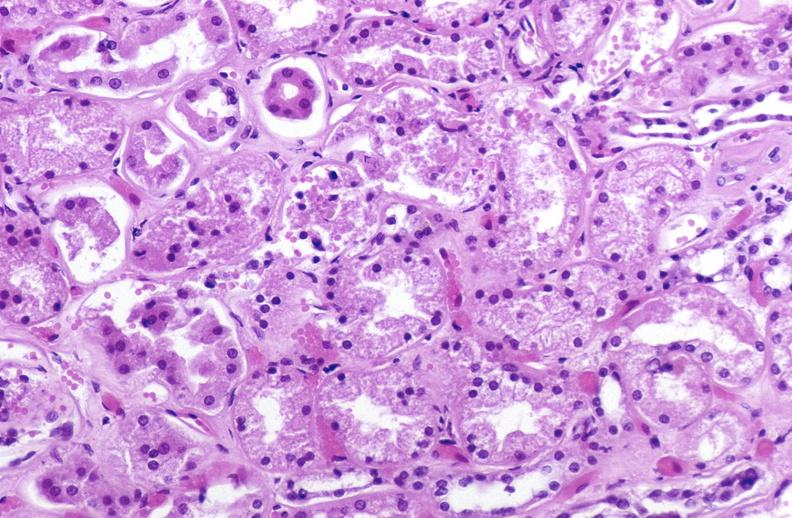does this image show atn acute tubular necrosis?
Answer the question using a single word or phrase. Yes 